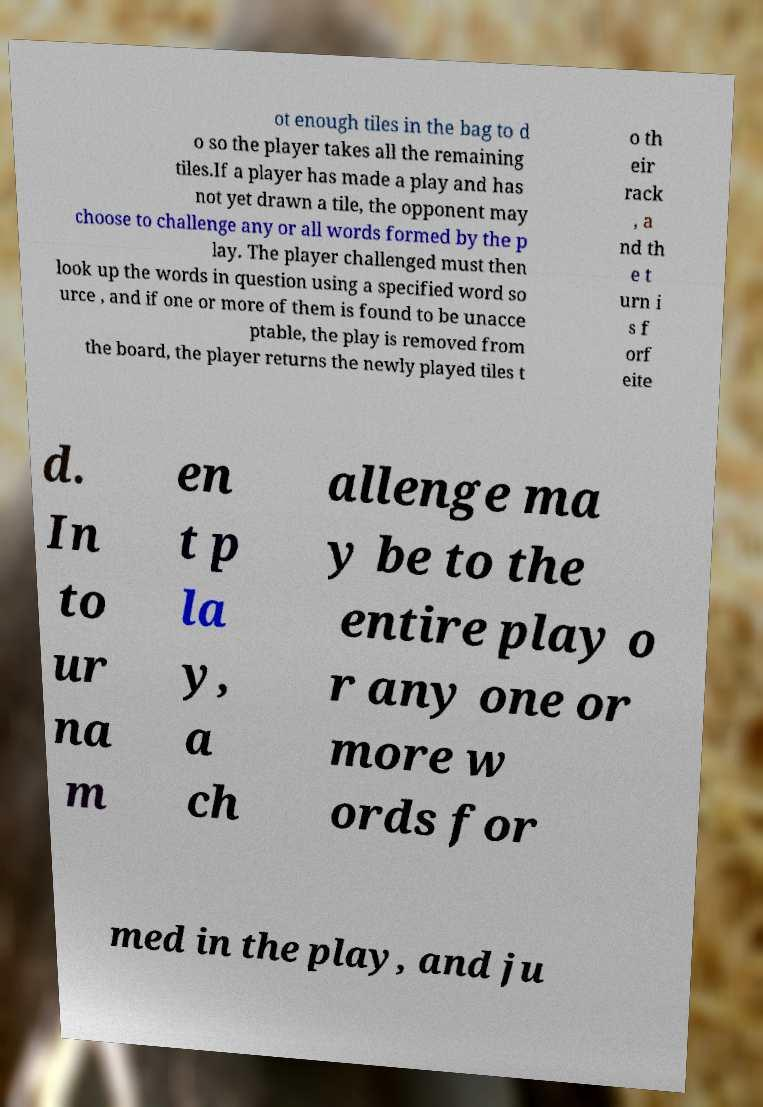Could you extract and type out the text from this image? ot enough tiles in the bag to d o so the player takes all the remaining tiles.If a player has made a play and has not yet drawn a tile, the opponent may choose to challenge any or all words formed by the p lay. The player challenged must then look up the words in question using a specified word so urce , and if one or more of them is found to be unacce ptable, the play is removed from the board, the player returns the newly played tiles t o th eir rack , a nd th e t urn i s f orf eite d. In to ur na m en t p la y, a ch allenge ma y be to the entire play o r any one or more w ords for med in the play, and ju 